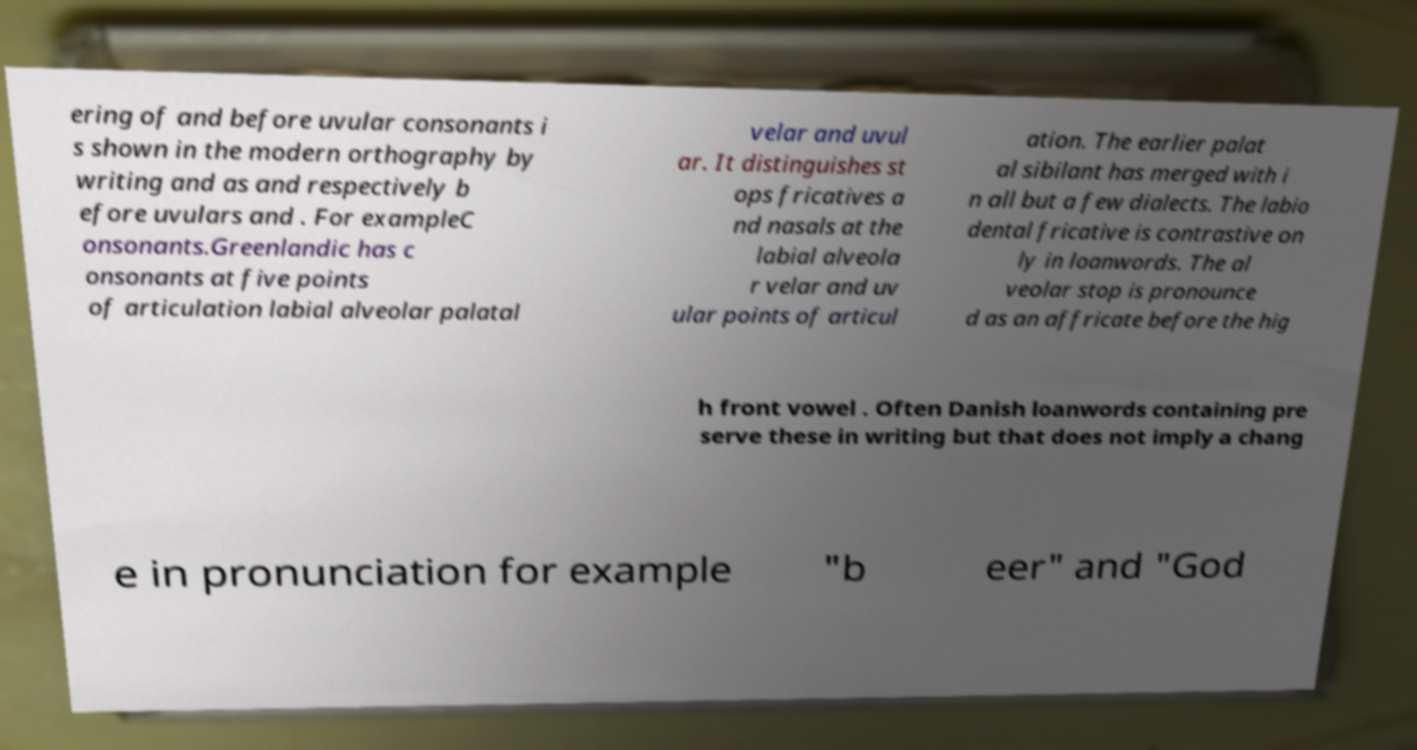What messages or text are displayed in this image? I need them in a readable, typed format. ering of and before uvular consonants i s shown in the modern orthography by writing and as and respectively b efore uvulars and . For exampleC onsonants.Greenlandic has c onsonants at five points of articulation labial alveolar palatal velar and uvul ar. It distinguishes st ops fricatives a nd nasals at the labial alveola r velar and uv ular points of articul ation. The earlier palat al sibilant has merged with i n all but a few dialects. The labio dental fricative is contrastive on ly in loanwords. The al veolar stop is pronounce d as an affricate before the hig h front vowel . Often Danish loanwords containing pre serve these in writing but that does not imply a chang e in pronunciation for example "b eer" and "God 